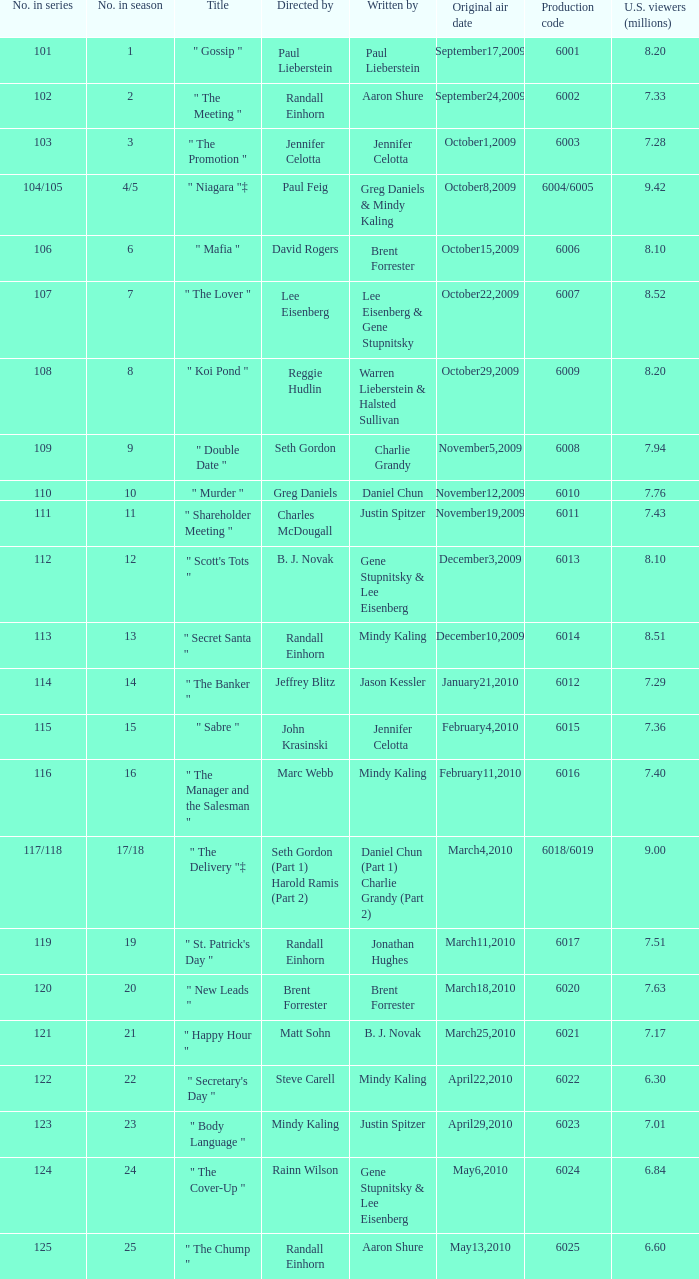Name the production code for number in season being 21 6021.0. 